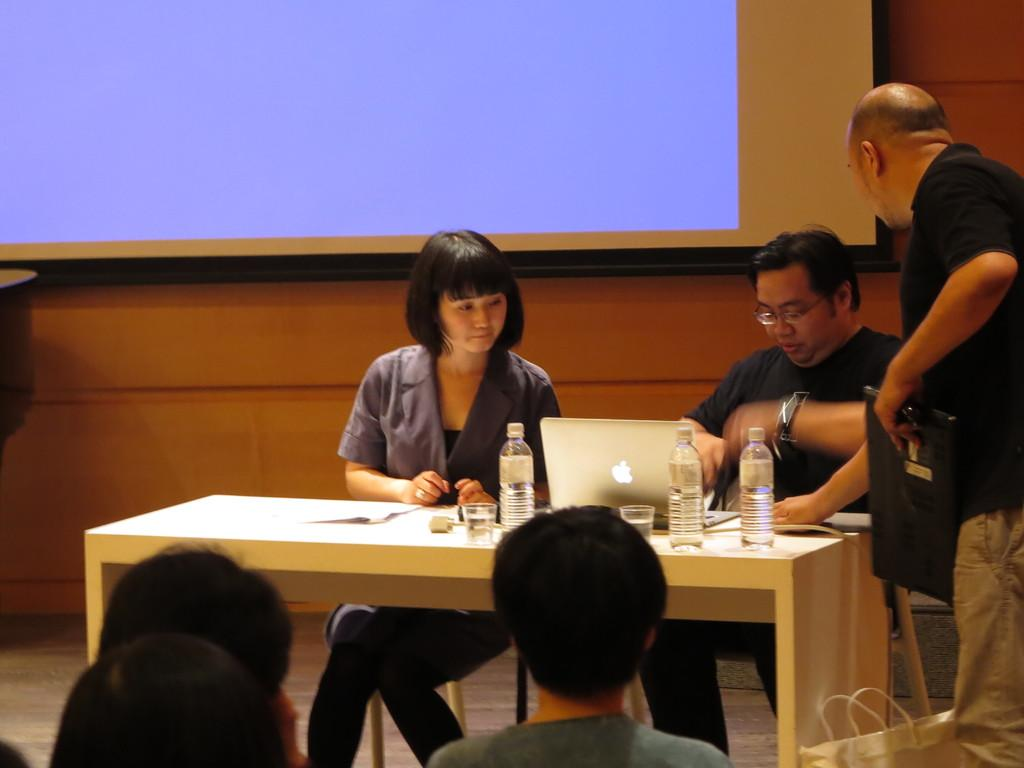How many people are in the image? There are two persons in the image. What are the persons doing in the image? The persons are sitting in chairs and looking at a laptop. What can be seen on the table in the image? There are water bottles on a table. What type of rail is visible in the image? There is no rail present in the image. What kind of pancake is being served at the feast in the image? There is no feast or pancake present in the image. 